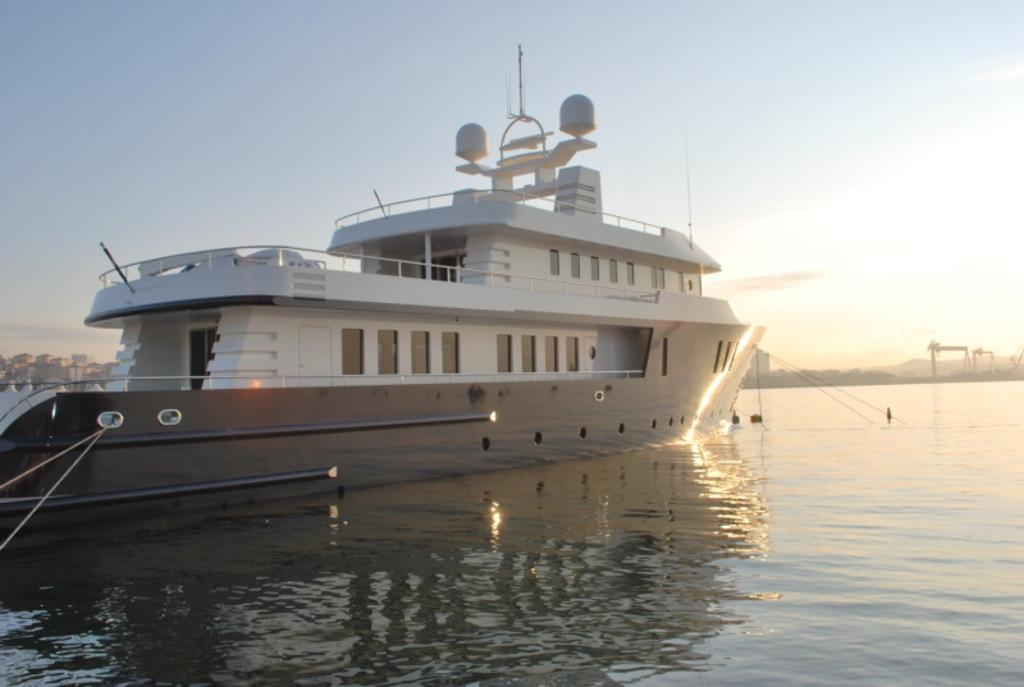What is the main subject of the image? There is a ship in the water. How would you describe the sky in the image? The sky is blue and cloudy. Are there any structures visible in the image? Yes, there are buildings visible in the image. What type of yarn is being used to create the shape of the ship in the image? There is no yarn or shape being created in the image; it is a photograph of a real ship in the water. 